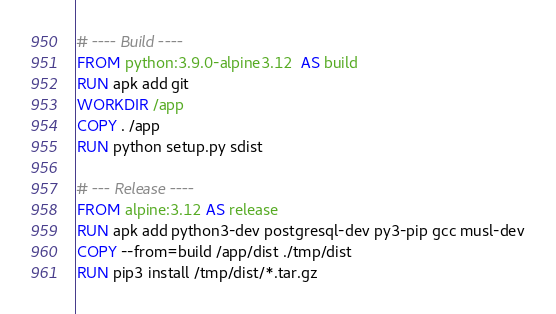<code> <loc_0><loc_0><loc_500><loc_500><_Dockerfile_># ---- Build ----
FROM python:3.9.0-alpine3.12  AS build
RUN apk add git
WORKDIR /app
COPY . /app
RUN python setup.py sdist

# --- Release ----
FROM alpine:3.12 AS release
RUN apk add python3-dev postgresql-dev py3-pip gcc musl-dev
COPY --from=build /app/dist ./tmp/dist
RUN pip3 install /tmp/dist/*.tar.gz
</code> 